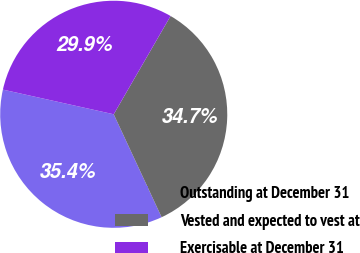Convert chart to OTSL. <chart><loc_0><loc_0><loc_500><loc_500><pie_chart><fcel>Outstanding at December 31<fcel>Vested and expected to vest at<fcel>Exercisable at December 31<nl><fcel>35.42%<fcel>34.72%<fcel>29.86%<nl></chart> 